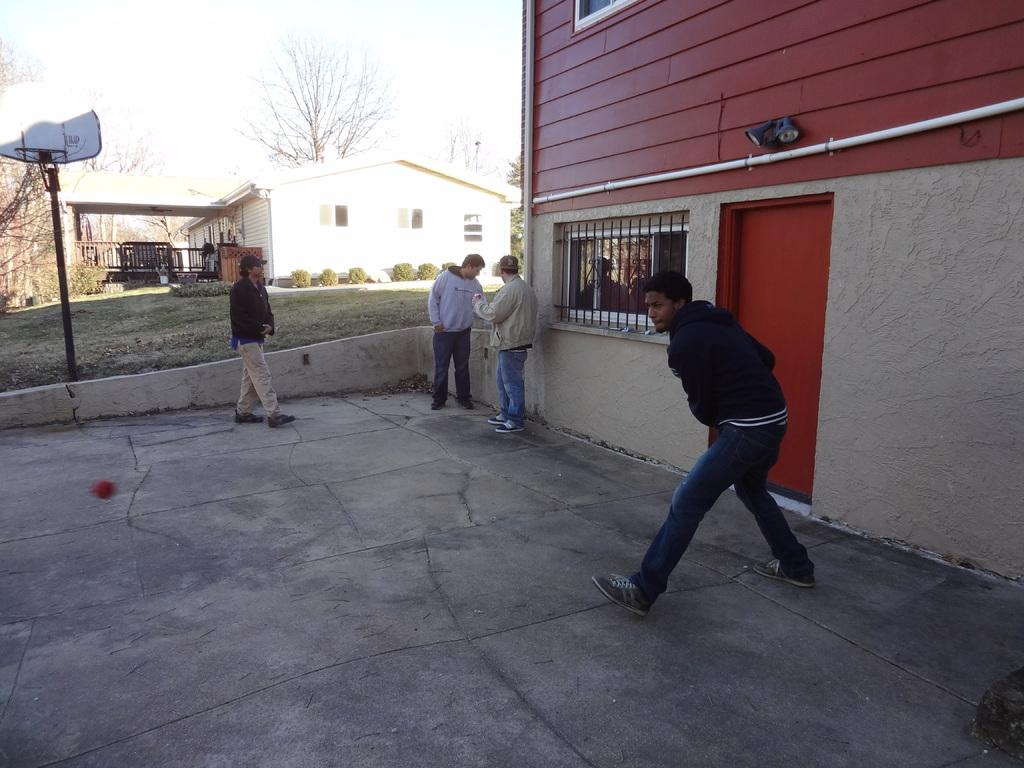How many people are standing on the path in the image? There are four people standing on the path in the image. What can be seen in the background of the image? There is a house, plants, a pole, and the sky visible in the background. What type of chairs are the people sitting on in the image? There are no chairs present in the image; the people are standing on the path. What is the feeling of the people in the image? The image does not convey any specific feelings or emotions of the people; it only shows them standing on the path. 